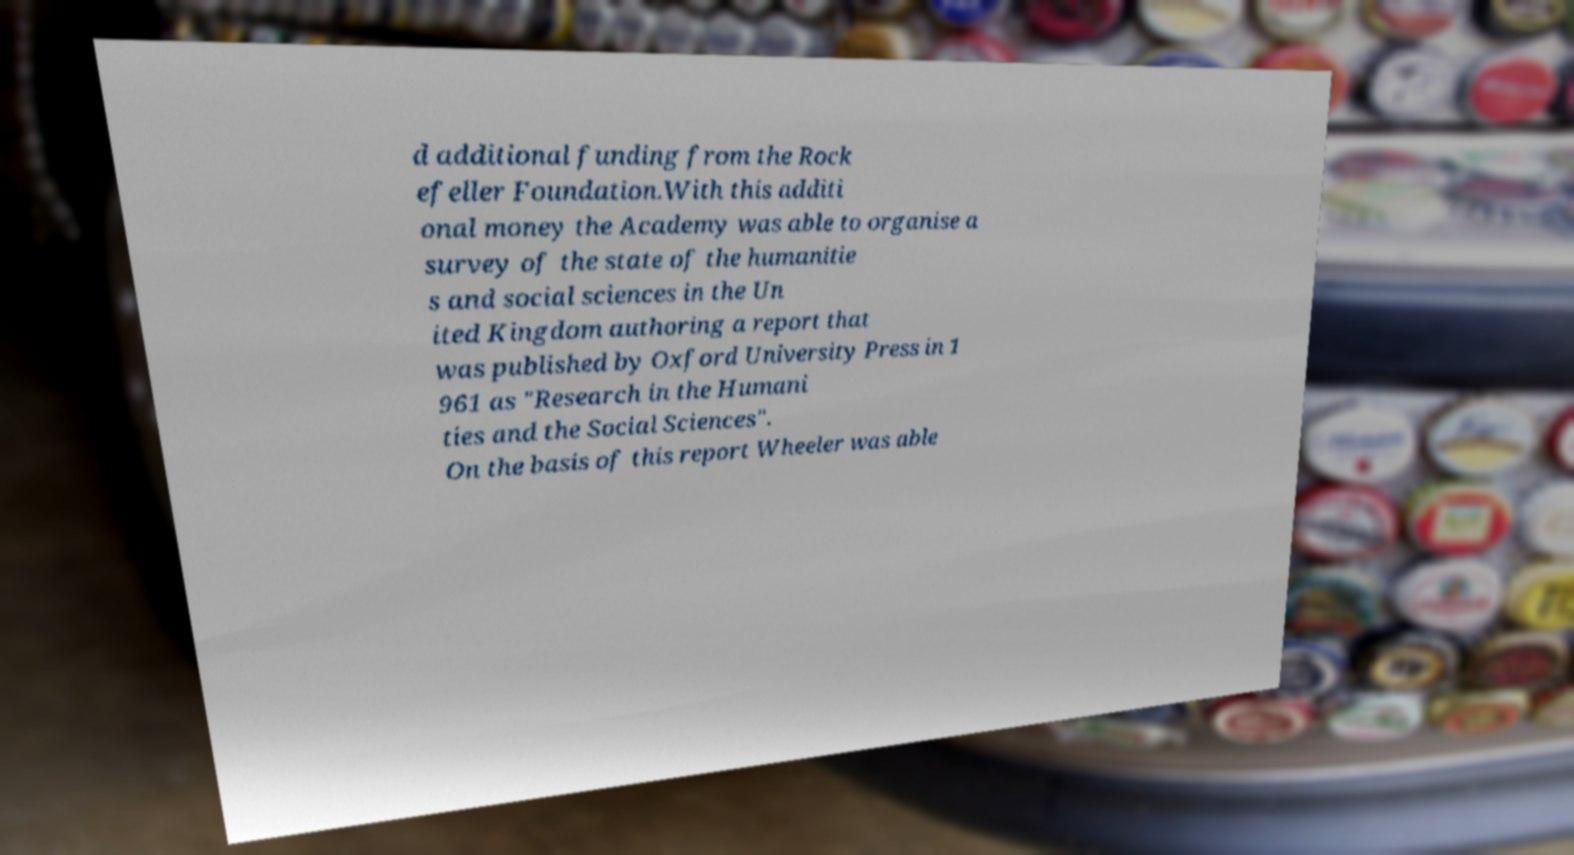There's text embedded in this image that I need extracted. Can you transcribe it verbatim? d additional funding from the Rock efeller Foundation.With this additi onal money the Academy was able to organise a survey of the state of the humanitie s and social sciences in the Un ited Kingdom authoring a report that was published by Oxford University Press in 1 961 as "Research in the Humani ties and the Social Sciences". On the basis of this report Wheeler was able 